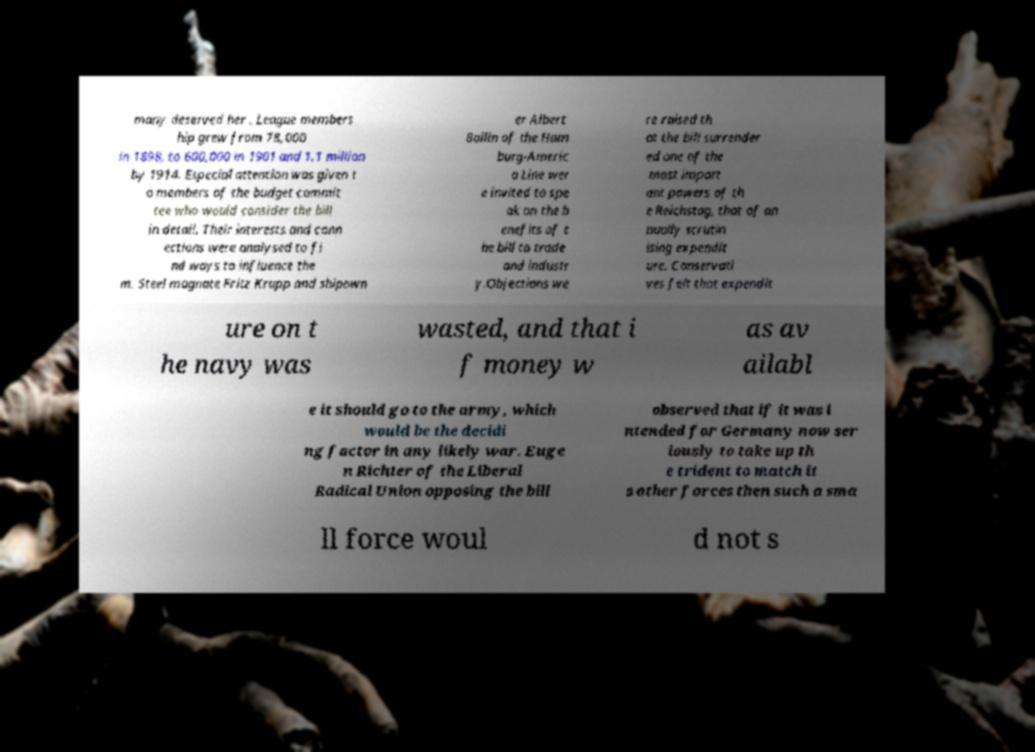I need the written content from this picture converted into text. Can you do that? many deserved her . League members hip grew from 78,000 in 1898, to 600,000 in 1901 and 1.1 million by 1914. Especial attention was given t o members of the budget commit tee who would consider the bill in detail. Their interests and conn ections were analysed to fi nd ways to influence the m. Steel magnate Fritz Krupp and shipown er Albert Ballin of the Ham burg-Americ a Line wer e invited to spe ak on the b enefits of t he bill to trade and industr y.Objections we re raised th at the bill surrender ed one of the most import ant powers of th e Reichstag, that of an nually scrutin ising expendit ure. Conservati ves felt that expendit ure on t he navy was wasted, and that i f money w as av ailabl e it should go to the army, which would be the decidi ng factor in any likely war. Euge n Richter of the Liberal Radical Union opposing the bill observed that if it was i ntended for Germany now ser iously to take up th e trident to match it s other forces then such a sma ll force woul d not s 